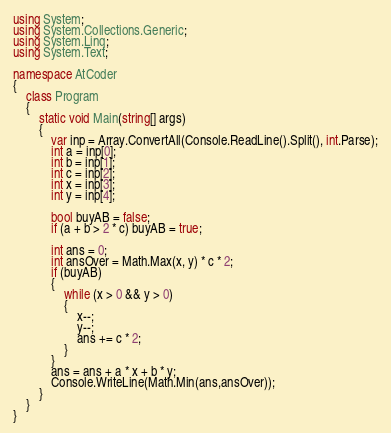Convert code to text. <code><loc_0><loc_0><loc_500><loc_500><_C#_>using System;
using System.Collections.Generic;
using System.Linq;
using System.Text;

namespace AtCoder
{
    class Program
    {
        static void Main(string[] args)
        {
            var inp = Array.ConvertAll(Console.ReadLine().Split(), int.Parse);
            int a = inp[0];
            int b = inp[1];
            int c = inp[2];
            int x = inp[3];
            int y = inp[4];

            bool buyAB = false;            
            if (a + b > 2 * c) buyAB = true;

            int ans = 0;
            int ansOver = Math.Max(x, y) * c * 2;
            if (buyAB)
            {
                while (x > 0 && y > 0)
                {
                    x--;
                    y--;
                    ans += c * 2;
                }
            }
            ans = ans + a * x + b * y;
            Console.WriteLine(Math.Min(ans,ansOver));
        }
    }
}</code> 